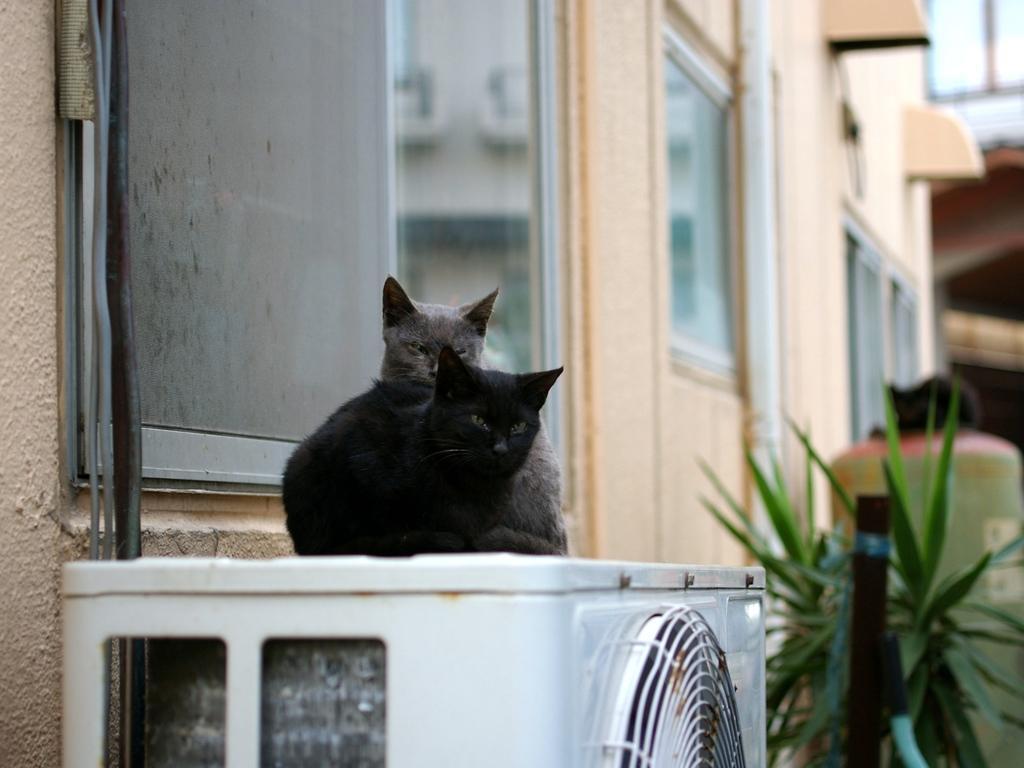Please provide a concise description of this image. In the center of the image we can see a white color object. On the object, we can see two cats. In the background there is a building, windows, leaves and a few other objects. 